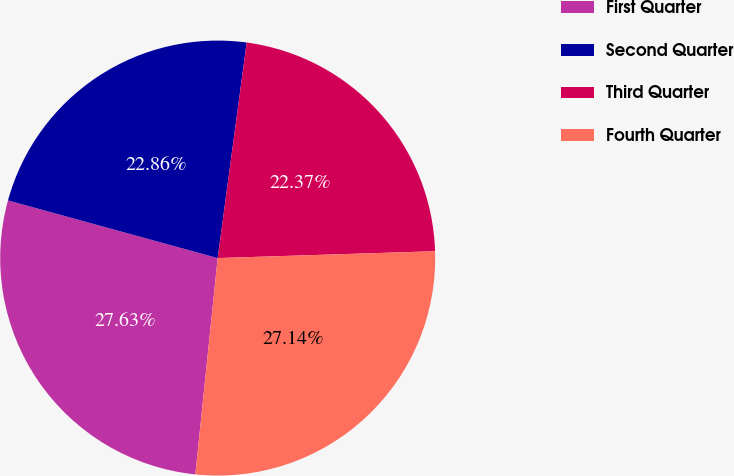<chart> <loc_0><loc_0><loc_500><loc_500><pie_chart><fcel>First Quarter<fcel>Second Quarter<fcel>Third Quarter<fcel>Fourth Quarter<nl><fcel>27.63%<fcel>22.86%<fcel>22.37%<fcel>27.14%<nl></chart> 